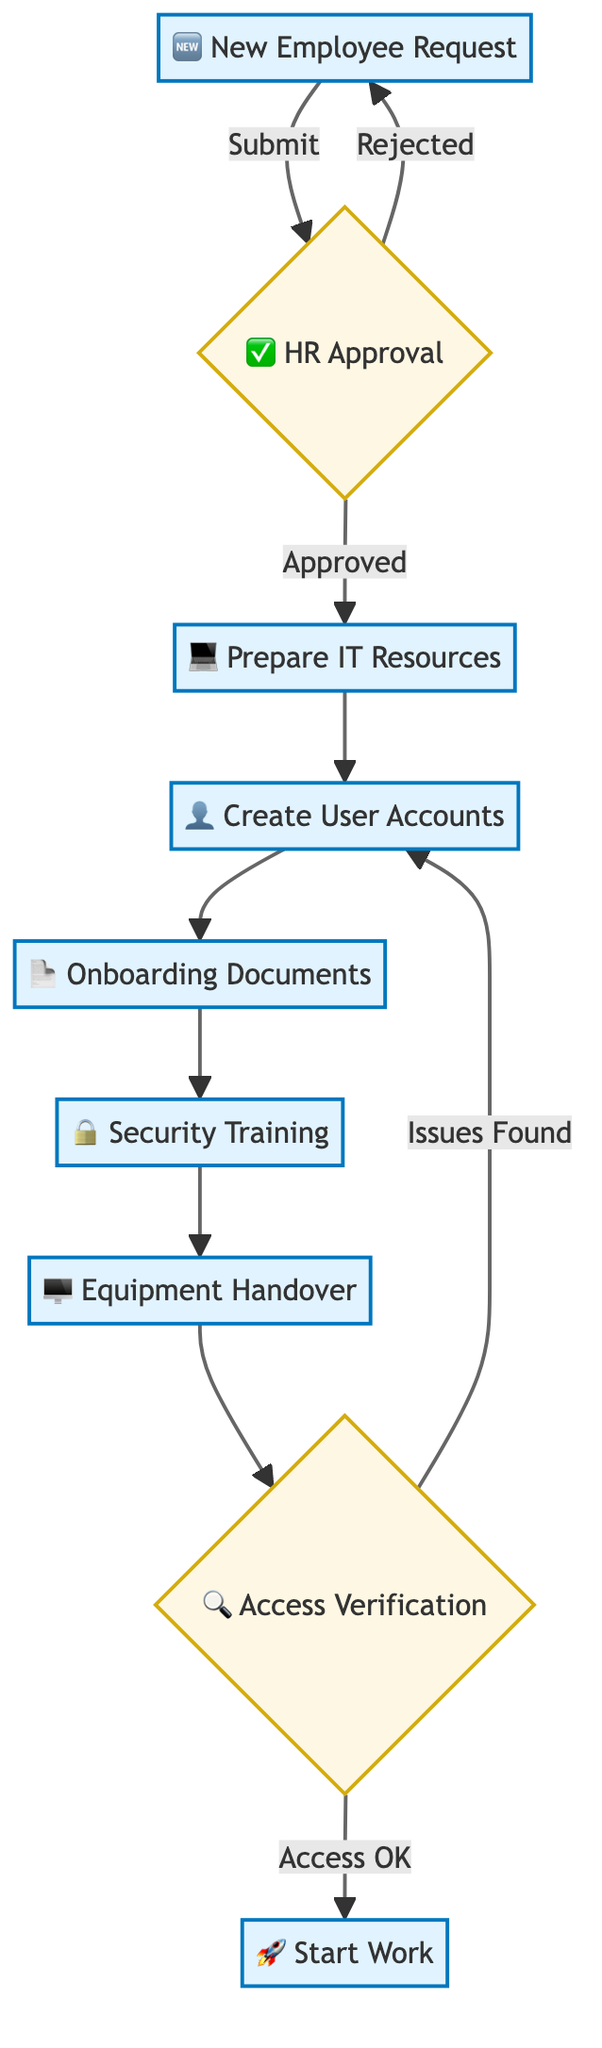What is the first step in the onboarding process? The onboarding process starts with the "New Employee Request" submitted by the manager. This is the first node in the flowchart, indicating that it's the initial action required to begin the onboarding process.
Answer: New Employee Request How many processes are there in the workflow? By analyzing the flowchart, we can count the nodes that are labeled as processes. There are seven process nodes in total: "New Employee Request," "Prepare IT Resources," "Create User Accounts," "Onboarding Documents," "Security Training," "Equipment Handover," and "Start Work."
Answer: Seven What happens if HR rejects the new employee request? If HR rejects the new employee request, the flow returns to the "New Employee Request" node, indicating a loop back to resubmit the request. This is illustrated in the flowchart where an arrow points back to the first step.
Answer: Resubmission What is the last step before the new employee starts work? The last step before the new employee starts work is "Access Verification." This step ensures that the new employee has access to all required systems before they officially begin working.
Answer: Access Verification What is verified during Access Verification? During Access Verification, IT verifies that the new employee can access all required systems. This step is crucial to ensure that the employee is fully equipped with the necessary access rights before starting.
Answer: System Access What are the potential outcomes of Access Verification? The potential outcomes of Access Verification are "Access OK" or "Issues Found." Depending on the verification result, the flow chart indicates whether the onboarding process continues to "Start Work" or loops back to "Create User Accounts" for troubleshooting.
Answer: Access OK or Issues Found Which role is responsible for sending onboarding documents? The HR department is responsible for sending onboarding documents and training materials to the new employee after user accounts are created and prior to completing security training. This is indicated in the flowchart under the "Onboarding Documents" step.
Answer: HR What step follows after the "Equipment Handover"? After the "Equipment Handover," the next step is "Access Verification." This indicates that once the new employee has received their equipment, IT checks if they can access the necessary systems.
Answer: Access Verification 